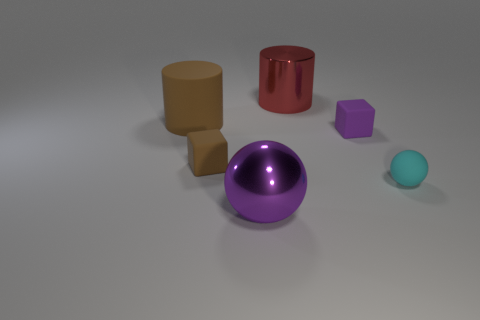Add 2 purple shiny things. How many objects exist? 8 Subtract all brown cylinders. Subtract all purple rubber things. How many objects are left? 4 Add 1 large purple metallic spheres. How many large purple metallic spheres are left? 2 Add 5 purple matte things. How many purple matte things exist? 6 Subtract all cyan spheres. How many spheres are left? 1 Subtract 0 green balls. How many objects are left? 6 Subtract all cylinders. How many objects are left? 4 Subtract 2 cylinders. How many cylinders are left? 0 Subtract all brown cylinders. Subtract all purple spheres. How many cylinders are left? 1 Subtract all blue cubes. How many brown cylinders are left? 1 